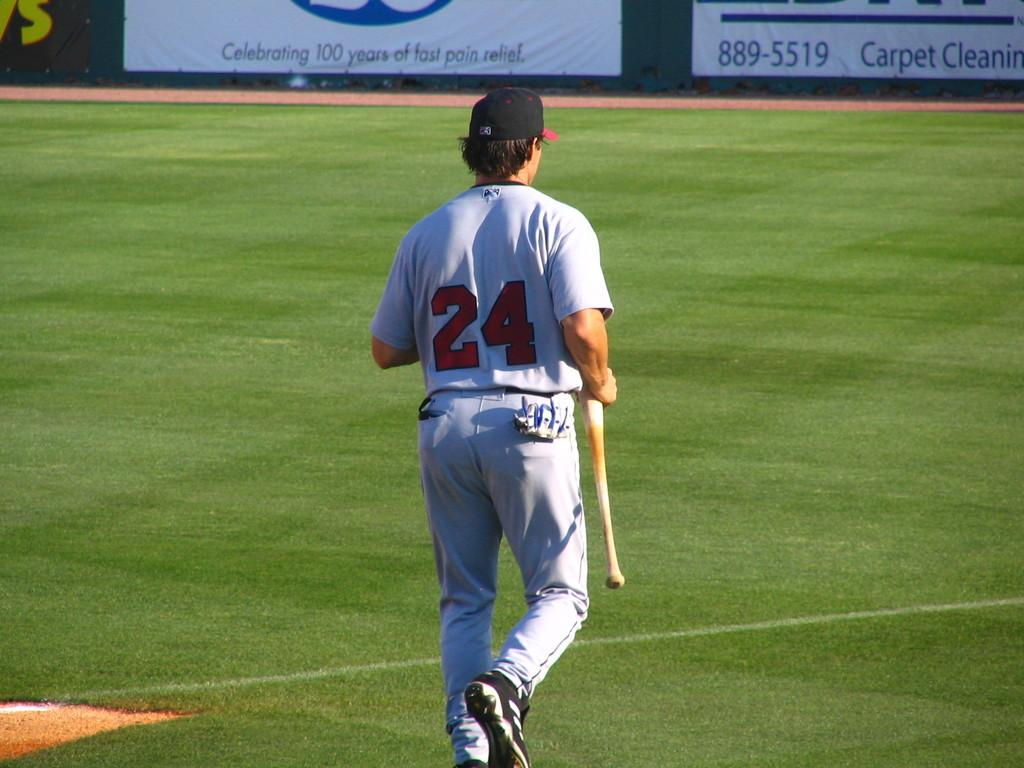Provide a one-sentence caption for the provided image. A person wearing a jersey with the number 24 walks in a baseball field. 